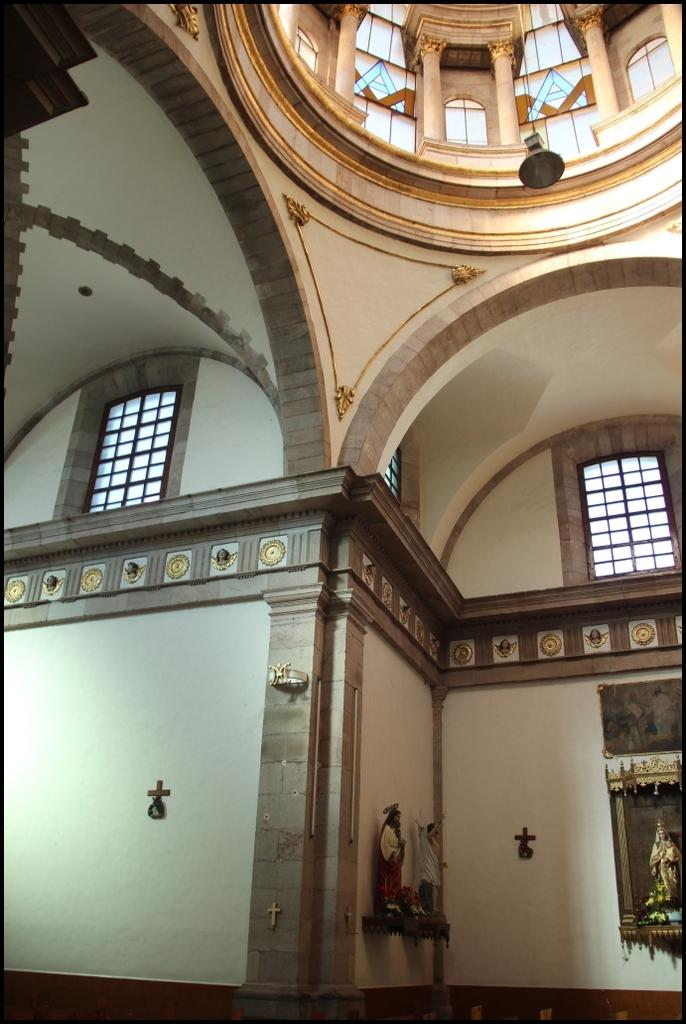What type of building is depicted in the image? The image appears to be inside a church. What religious figures can be seen in the image? There are statues of Jesus Christ in the image. Are there any other statues besides Jesus Christ in the image? Yes, there are statues of other persons in the image. How much money is being offered to the statues in the image? There is no money present in the image, as it features statues inside a church. 